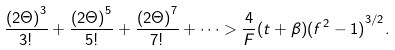Convert formula to latex. <formula><loc_0><loc_0><loc_500><loc_500>\frac { { ( 2 \Theta ) } ^ { 3 } } { 3 ! } + \frac { { ( 2 \Theta ) } ^ { 5 } } { 5 ! } + \frac { { ( 2 \Theta ) } ^ { 7 } } { 7 ! } + \dots > \frac { 4 } { F } ( t + \beta ) { ( f ^ { 2 } - 1 ) } ^ { 3 / 2 } .</formula> 